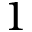<formula> <loc_0><loc_0><loc_500><loc_500>1</formula> 